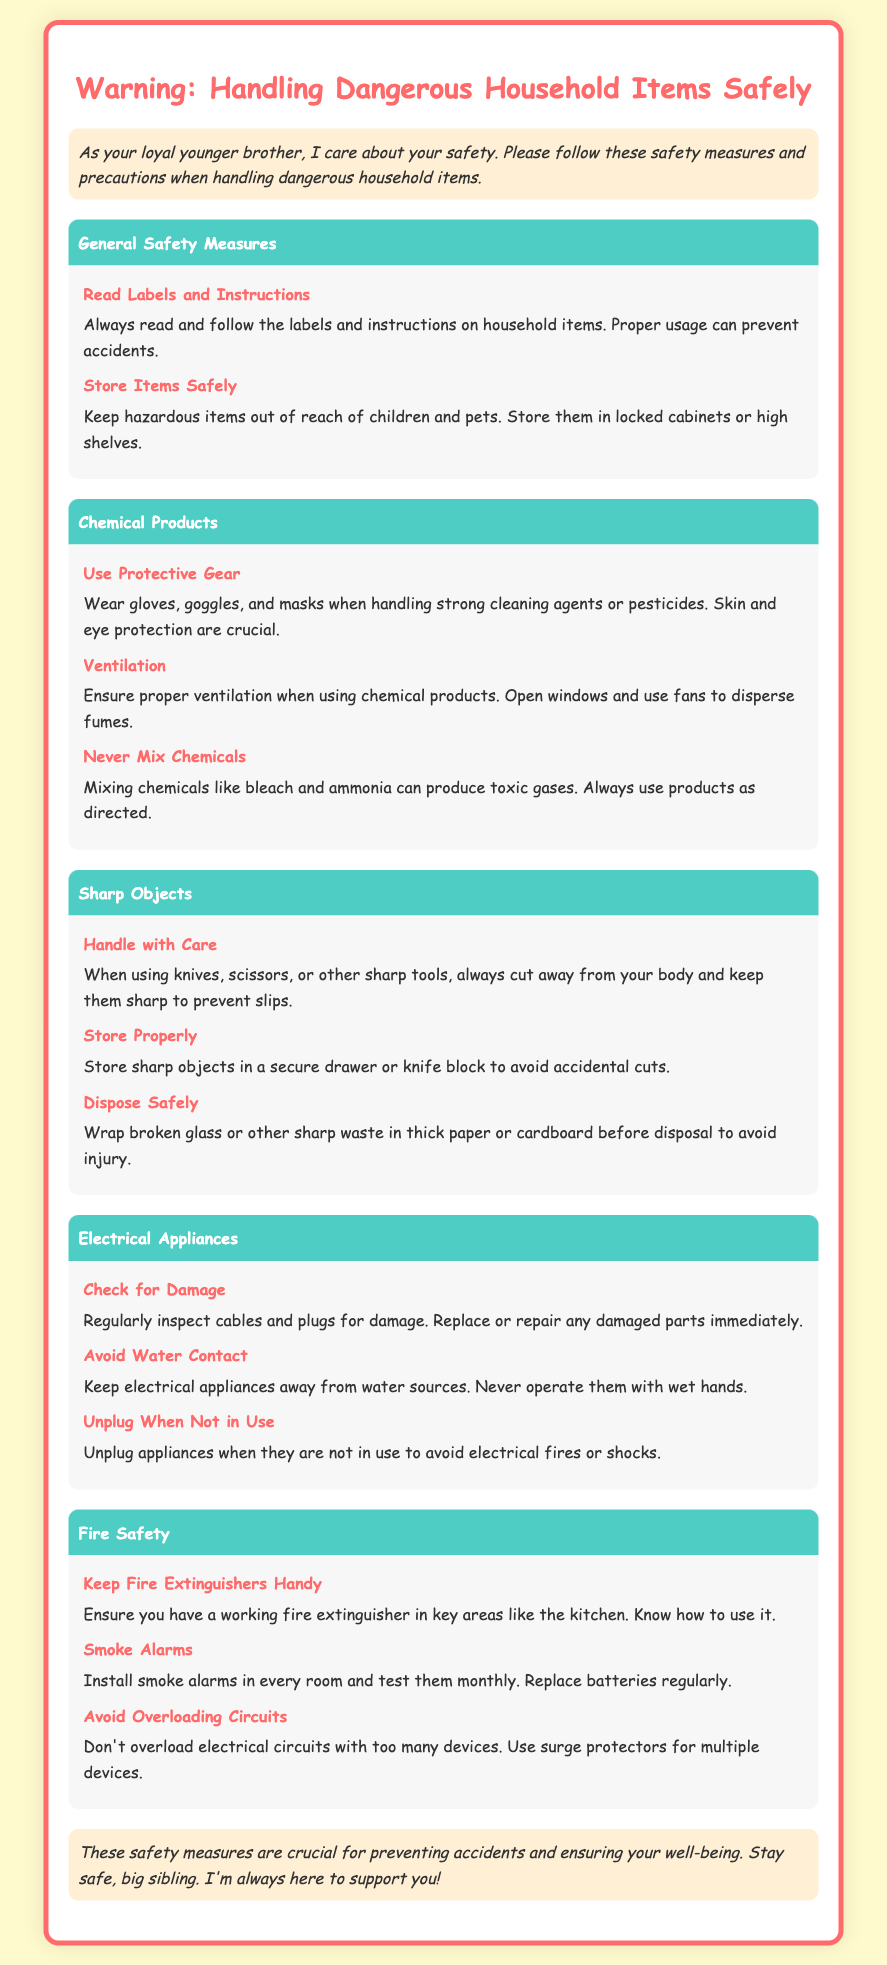what should you always read before using household items? The document states that you should always read the labels and instructions on household items to prevent accidents.
Answer: labels and instructions how should hazardous items be stored? The document advises that hazardous items should be kept out of reach of children and pets, stored in locked cabinets or high shelves.
Answer: locked cabinets or high shelves which protective gear should be worn when handling strong cleaning agents? The document specifies that gloves, goggles, and masks should be worn when handling strong cleaning agents or pesticides.
Answer: gloves, goggles, and masks what should you never mix according to the document? The document mentions that you should never mix chemicals like bleach and ammonia due to the production of toxic gases.
Answer: bleach and ammonia how often should smoke alarms be tested? The document states that smoke alarms should be tested monthly.
Answer: monthly what is a crucial safety measure for electrical appliances? The document emphasizes that regularly inspecting cables and plugs for damage is a crucial safety measure.
Answer: regularly inspecting cables and plugs what should you do when an appliance is not in use? The document states that appliances should be unplugged when not in use to avoid electrical fires or shocks.
Answer: unplugged where should fire extinguishers be located? The document advises that fire extinguishers should be in key areas like the kitchen.
Answer: key areas like the kitchen how should broken glass be disposed of? According to the document, broken glass should be wrapped in thick paper or cardboard before disposal to avoid injury.
Answer: wrapped in thick paper or cardboard 